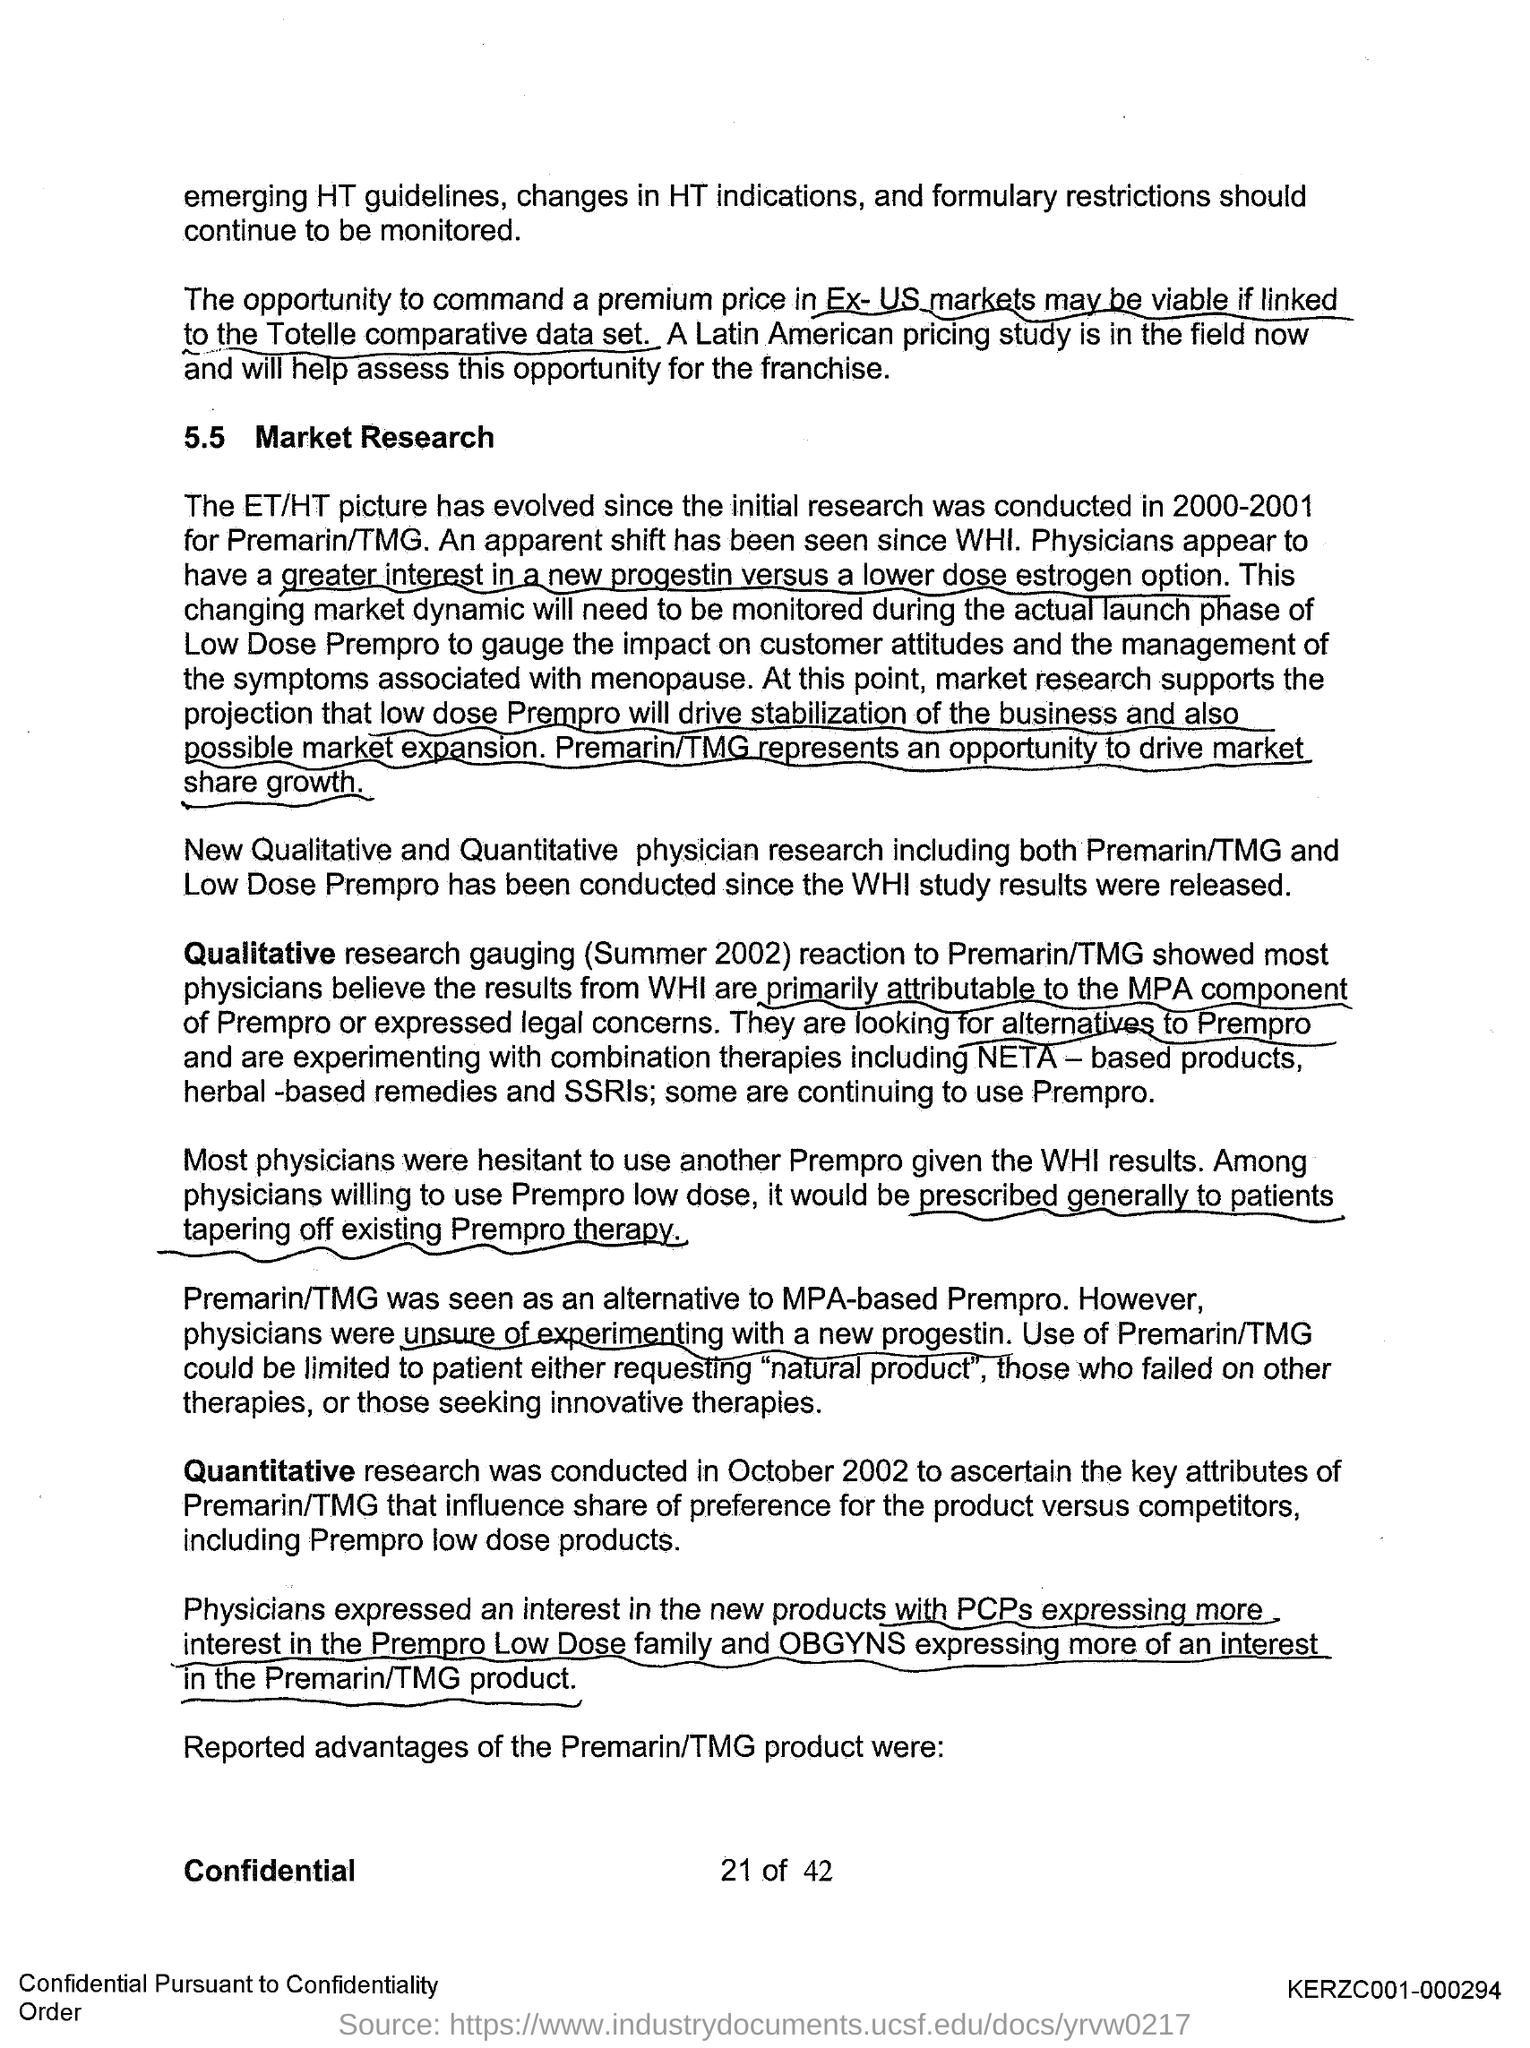Draw attention to some important aspects in this diagram. The first title in the document is 'Market Research.' 